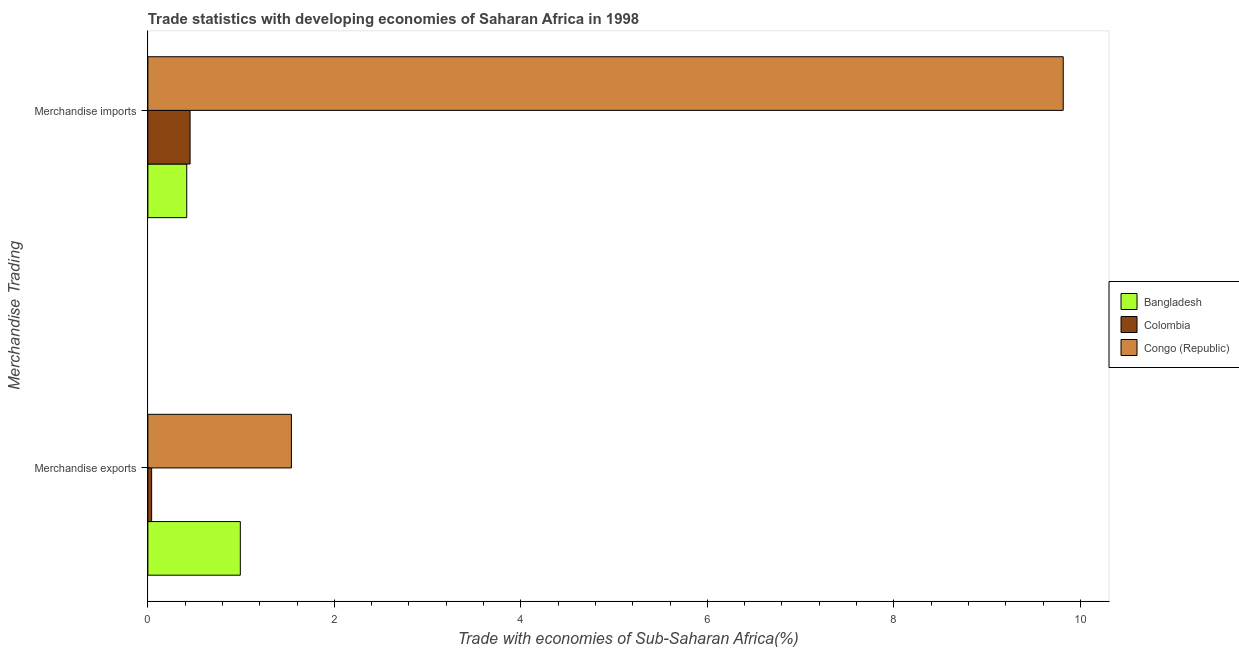How many groups of bars are there?
Your answer should be very brief. 2. Are the number of bars per tick equal to the number of legend labels?
Give a very brief answer. Yes. Are the number of bars on each tick of the Y-axis equal?
Provide a succinct answer. Yes. How many bars are there on the 2nd tick from the bottom?
Your answer should be compact. 3. What is the label of the 2nd group of bars from the top?
Your response must be concise. Merchandise exports. What is the merchandise imports in Bangladesh?
Provide a short and direct response. 0.42. Across all countries, what is the maximum merchandise exports?
Keep it short and to the point. 1.54. Across all countries, what is the minimum merchandise imports?
Offer a very short reply. 0.42. In which country was the merchandise imports maximum?
Your answer should be compact. Congo (Republic). In which country was the merchandise imports minimum?
Ensure brevity in your answer.  Bangladesh. What is the total merchandise imports in the graph?
Your response must be concise. 10.69. What is the difference between the merchandise imports in Congo (Republic) and that in Colombia?
Provide a short and direct response. 9.36. What is the difference between the merchandise imports in Colombia and the merchandise exports in Bangladesh?
Provide a succinct answer. -0.54. What is the average merchandise exports per country?
Your response must be concise. 0.86. What is the difference between the merchandise exports and merchandise imports in Congo (Republic)?
Make the answer very short. -8.28. In how many countries, is the merchandise imports greater than 0.8 %?
Keep it short and to the point. 1. What is the ratio of the merchandise exports in Bangladesh to that in Colombia?
Provide a short and direct response. 24.53. Is the merchandise exports in Colombia less than that in Congo (Republic)?
Offer a terse response. Yes. In how many countries, is the merchandise exports greater than the average merchandise exports taken over all countries?
Offer a terse response. 2. What does the 2nd bar from the top in Merchandise imports represents?
Give a very brief answer. Colombia. Are all the bars in the graph horizontal?
Provide a short and direct response. Yes. How many countries are there in the graph?
Your response must be concise. 3. Where does the legend appear in the graph?
Your answer should be very brief. Center right. How many legend labels are there?
Keep it short and to the point. 3. What is the title of the graph?
Your answer should be compact. Trade statistics with developing economies of Saharan Africa in 1998. What is the label or title of the X-axis?
Offer a very short reply. Trade with economies of Sub-Saharan Africa(%). What is the label or title of the Y-axis?
Ensure brevity in your answer.  Merchandise Trading. What is the Trade with economies of Sub-Saharan Africa(%) of Bangladesh in Merchandise exports?
Your response must be concise. 0.99. What is the Trade with economies of Sub-Saharan Africa(%) in Colombia in Merchandise exports?
Your answer should be very brief. 0.04. What is the Trade with economies of Sub-Saharan Africa(%) of Congo (Republic) in Merchandise exports?
Give a very brief answer. 1.54. What is the Trade with economies of Sub-Saharan Africa(%) in Bangladesh in Merchandise imports?
Offer a very short reply. 0.42. What is the Trade with economies of Sub-Saharan Africa(%) in Colombia in Merchandise imports?
Offer a terse response. 0.45. What is the Trade with economies of Sub-Saharan Africa(%) of Congo (Republic) in Merchandise imports?
Your answer should be compact. 9.82. Across all Merchandise Trading, what is the maximum Trade with economies of Sub-Saharan Africa(%) of Bangladesh?
Your answer should be compact. 0.99. Across all Merchandise Trading, what is the maximum Trade with economies of Sub-Saharan Africa(%) in Colombia?
Your answer should be compact. 0.45. Across all Merchandise Trading, what is the maximum Trade with economies of Sub-Saharan Africa(%) of Congo (Republic)?
Keep it short and to the point. 9.82. Across all Merchandise Trading, what is the minimum Trade with economies of Sub-Saharan Africa(%) in Bangladesh?
Provide a short and direct response. 0.42. Across all Merchandise Trading, what is the minimum Trade with economies of Sub-Saharan Africa(%) of Colombia?
Provide a succinct answer. 0.04. Across all Merchandise Trading, what is the minimum Trade with economies of Sub-Saharan Africa(%) of Congo (Republic)?
Your answer should be very brief. 1.54. What is the total Trade with economies of Sub-Saharan Africa(%) in Bangladesh in the graph?
Your answer should be very brief. 1.41. What is the total Trade with economies of Sub-Saharan Africa(%) of Colombia in the graph?
Ensure brevity in your answer.  0.49. What is the total Trade with economies of Sub-Saharan Africa(%) of Congo (Republic) in the graph?
Keep it short and to the point. 11.36. What is the difference between the Trade with economies of Sub-Saharan Africa(%) in Bangladesh in Merchandise exports and that in Merchandise imports?
Provide a succinct answer. 0.57. What is the difference between the Trade with economies of Sub-Saharan Africa(%) of Colombia in Merchandise exports and that in Merchandise imports?
Your answer should be compact. -0.41. What is the difference between the Trade with economies of Sub-Saharan Africa(%) in Congo (Republic) in Merchandise exports and that in Merchandise imports?
Provide a short and direct response. -8.28. What is the difference between the Trade with economies of Sub-Saharan Africa(%) in Bangladesh in Merchandise exports and the Trade with economies of Sub-Saharan Africa(%) in Colombia in Merchandise imports?
Provide a succinct answer. 0.54. What is the difference between the Trade with economies of Sub-Saharan Africa(%) of Bangladesh in Merchandise exports and the Trade with economies of Sub-Saharan Africa(%) of Congo (Republic) in Merchandise imports?
Your response must be concise. -8.83. What is the difference between the Trade with economies of Sub-Saharan Africa(%) of Colombia in Merchandise exports and the Trade with economies of Sub-Saharan Africa(%) of Congo (Republic) in Merchandise imports?
Keep it short and to the point. -9.78. What is the average Trade with economies of Sub-Saharan Africa(%) in Bangladesh per Merchandise Trading?
Your answer should be very brief. 0.7. What is the average Trade with economies of Sub-Saharan Africa(%) of Colombia per Merchandise Trading?
Provide a succinct answer. 0.25. What is the average Trade with economies of Sub-Saharan Africa(%) of Congo (Republic) per Merchandise Trading?
Provide a short and direct response. 5.68. What is the difference between the Trade with economies of Sub-Saharan Africa(%) of Bangladesh and Trade with economies of Sub-Saharan Africa(%) of Colombia in Merchandise exports?
Keep it short and to the point. 0.95. What is the difference between the Trade with economies of Sub-Saharan Africa(%) of Bangladesh and Trade with economies of Sub-Saharan Africa(%) of Congo (Republic) in Merchandise exports?
Provide a short and direct response. -0.55. What is the difference between the Trade with economies of Sub-Saharan Africa(%) of Colombia and Trade with economies of Sub-Saharan Africa(%) of Congo (Republic) in Merchandise exports?
Offer a terse response. -1.5. What is the difference between the Trade with economies of Sub-Saharan Africa(%) in Bangladesh and Trade with economies of Sub-Saharan Africa(%) in Colombia in Merchandise imports?
Your answer should be compact. -0.04. What is the difference between the Trade with economies of Sub-Saharan Africa(%) in Bangladesh and Trade with economies of Sub-Saharan Africa(%) in Congo (Republic) in Merchandise imports?
Ensure brevity in your answer.  -9.4. What is the difference between the Trade with economies of Sub-Saharan Africa(%) of Colombia and Trade with economies of Sub-Saharan Africa(%) of Congo (Republic) in Merchandise imports?
Make the answer very short. -9.36. What is the ratio of the Trade with economies of Sub-Saharan Africa(%) of Bangladesh in Merchandise exports to that in Merchandise imports?
Your answer should be very brief. 2.38. What is the ratio of the Trade with economies of Sub-Saharan Africa(%) of Colombia in Merchandise exports to that in Merchandise imports?
Make the answer very short. 0.09. What is the ratio of the Trade with economies of Sub-Saharan Africa(%) of Congo (Republic) in Merchandise exports to that in Merchandise imports?
Your answer should be compact. 0.16. What is the difference between the highest and the second highest Trade with economies of Sub-Saharan Africa(%) in Bangladesh?
Your response must be concise. 0.57. What is the difference between the highest and the second highest Trade with economies of Sub-Saharan Africa(%) of Colombia?
Your answer should be compact. 0.41. What is the difference between the highest and the second highest Trade with economies of Sub-Saharan Africa(%) of Congo (Republic)?
Give a very brief answer. 8.28. What is the difference between the highest and the lowest Trade with economies of Sub-Saharan Africa(%) of Bangladesh?
Offer a terse response. 0.57. What is the difference between the highest and the lowest Trade with economies of Sub-Saharan Africa(%) of Colombia?
Your response must be concise. 0.41. What is the difference between the highest and the lowest Trade with economies of Sub-Saharan Africa(%) of Congo (Republic)?
Keep it short and to the point. 8.28. 